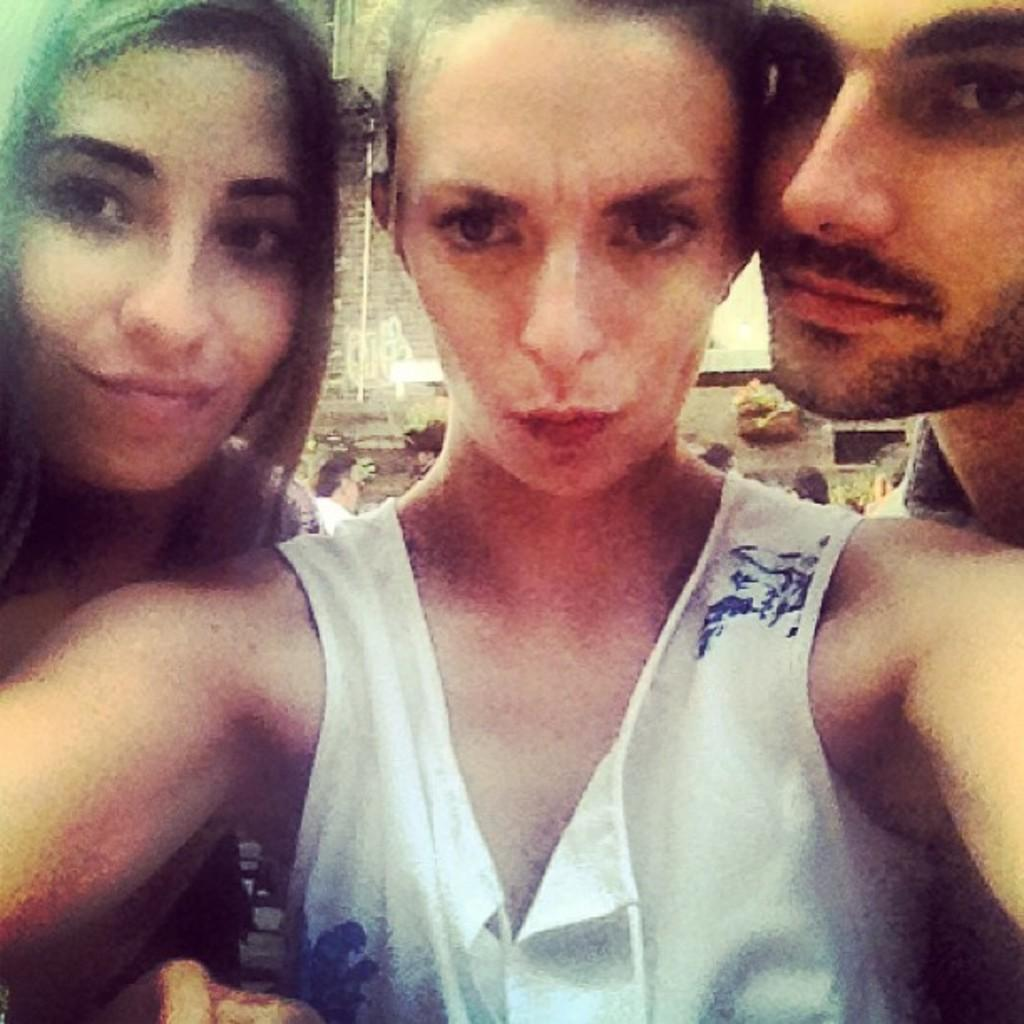How many people are present in the image? There are two women and a man in the image. What are the people in the image doing? The two women and the man are standing. Can you describe the clothing of one of the women? One of the women is wearing a white color dress. What type of fear does the man in the image have? There is no indication of fear in the image; the people are simply standing. What historical event is depicted in the image? There is no historical event depicted in the image; it features two women and a man standing. 